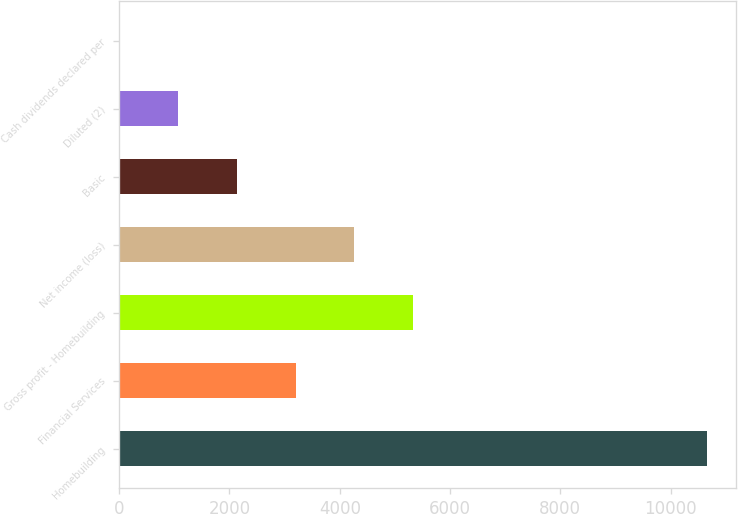<chart> <loc_0><loc_0><loc_500><loc_500><bar_chart><fcel>Homebuilding<fcel>Financial Services<fcel>Gross profit - Homebuilding<fcel>Net income (loss)<fcel>Basic<fcel>Diluted (2)<fcel>Cash dividends declared per<nl><fcel>10658<fcel>3197.55<fcel>5329.11<fcel>4263.33<fcel>2131.77<fcel>1065.99<fcel>0.21<nl></chart> 